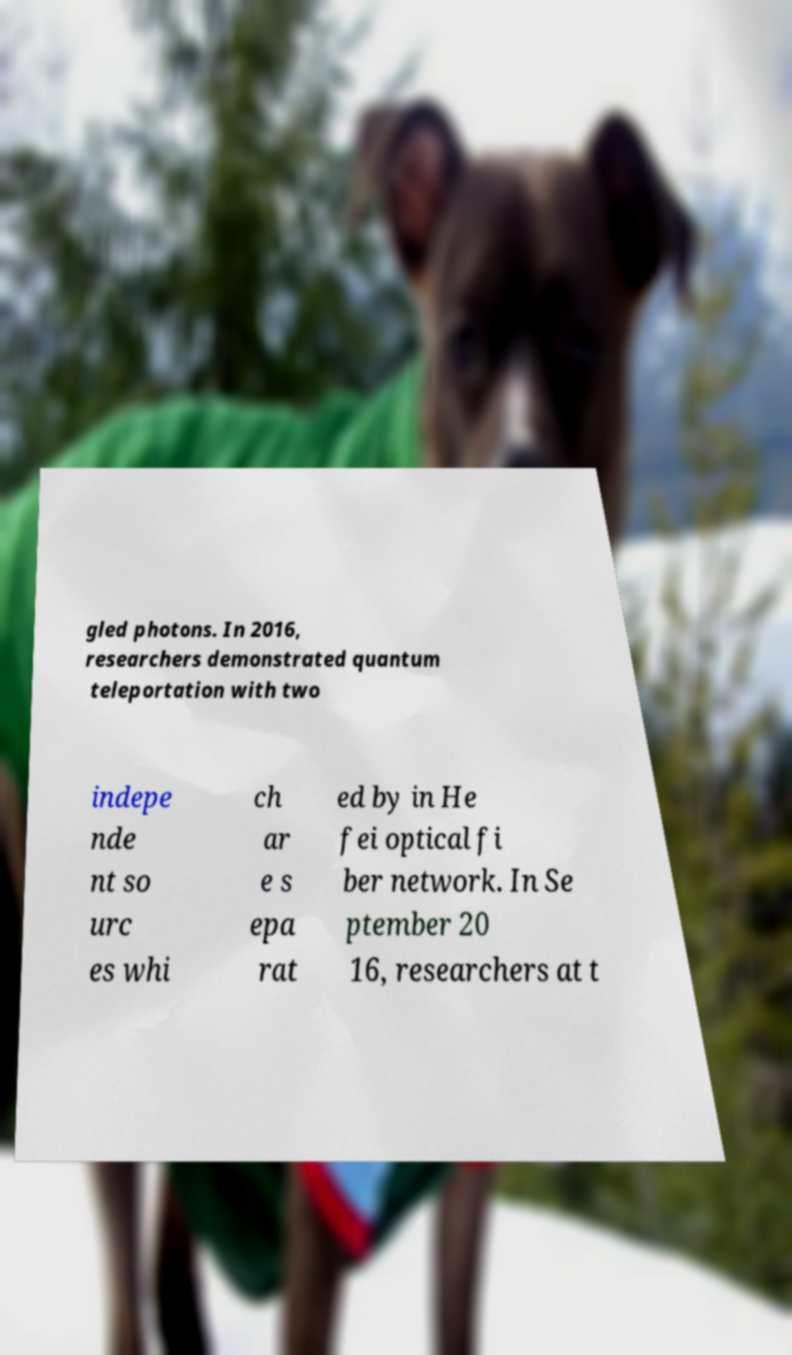For documentation purposes, I need the text within this image transcribed. Could you provide that? gled photons. In 2016, researchers demonstrated quantum teleportation with two indepe nde nt so urc es whi ch ar e s epa rat ed by in He fei optical fi ber network. In Se ptember 20 16, researchers at t 